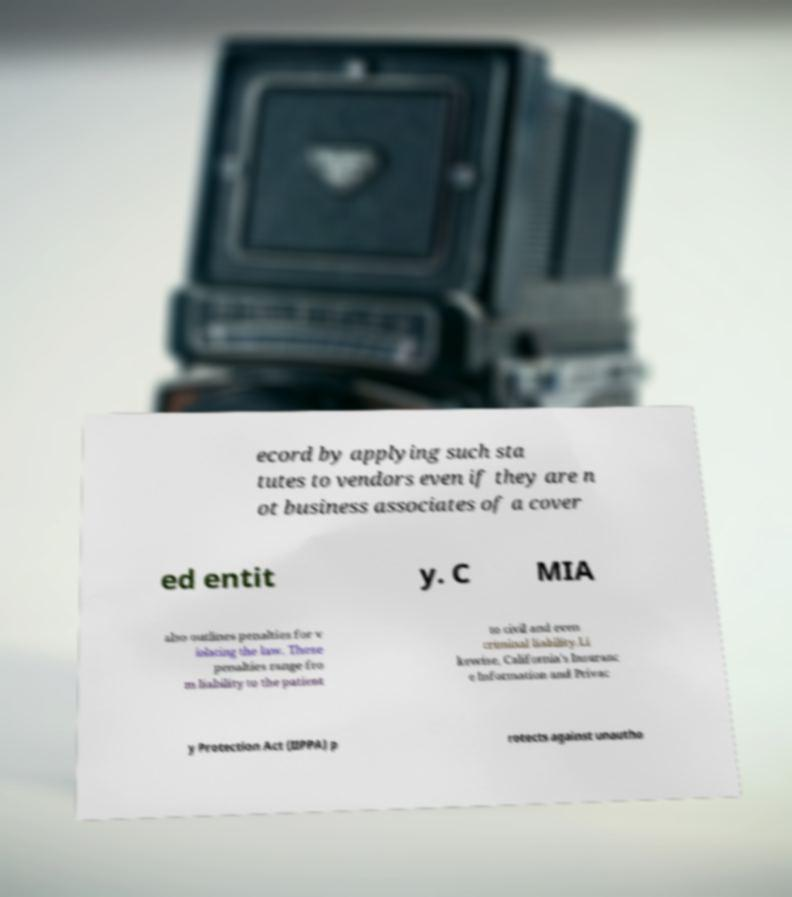What messages or text are displayed in this image? I need them in a readable, typed format. ecord by applying such sta tutes to vendors even if they are n ot business associates of a cover ed entit y. C MIA also outlines penalties for v iolating the law. These penalties range fro m liability to the patient to civil and even criminal liability.Li kewise, California's Insuranc e Information and Privac y Protection Act (IIPPA) p rotects against unautho 